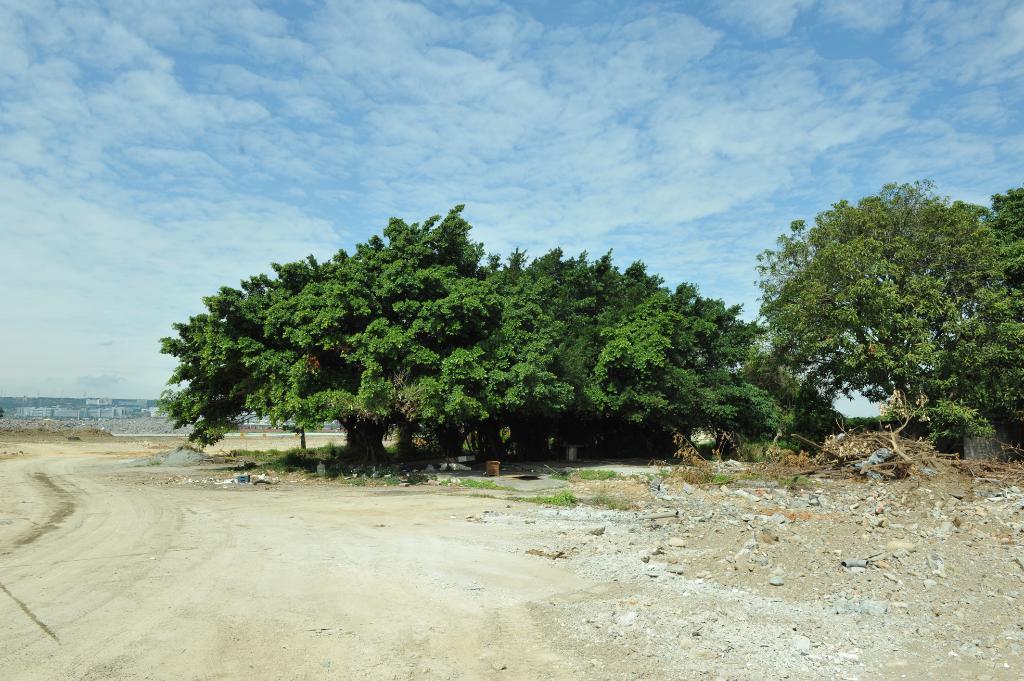In one or two sentences, can you explain what this image depicts? In the middle I can see trees, stones and grass. In the background I can see houses, poles and the sky. This image is taken during a day on the ground. 